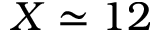Convert formula to latex. <formula><loc_0><loc_0><loc_500><loc_500>X \simeq 1 2</formula> 